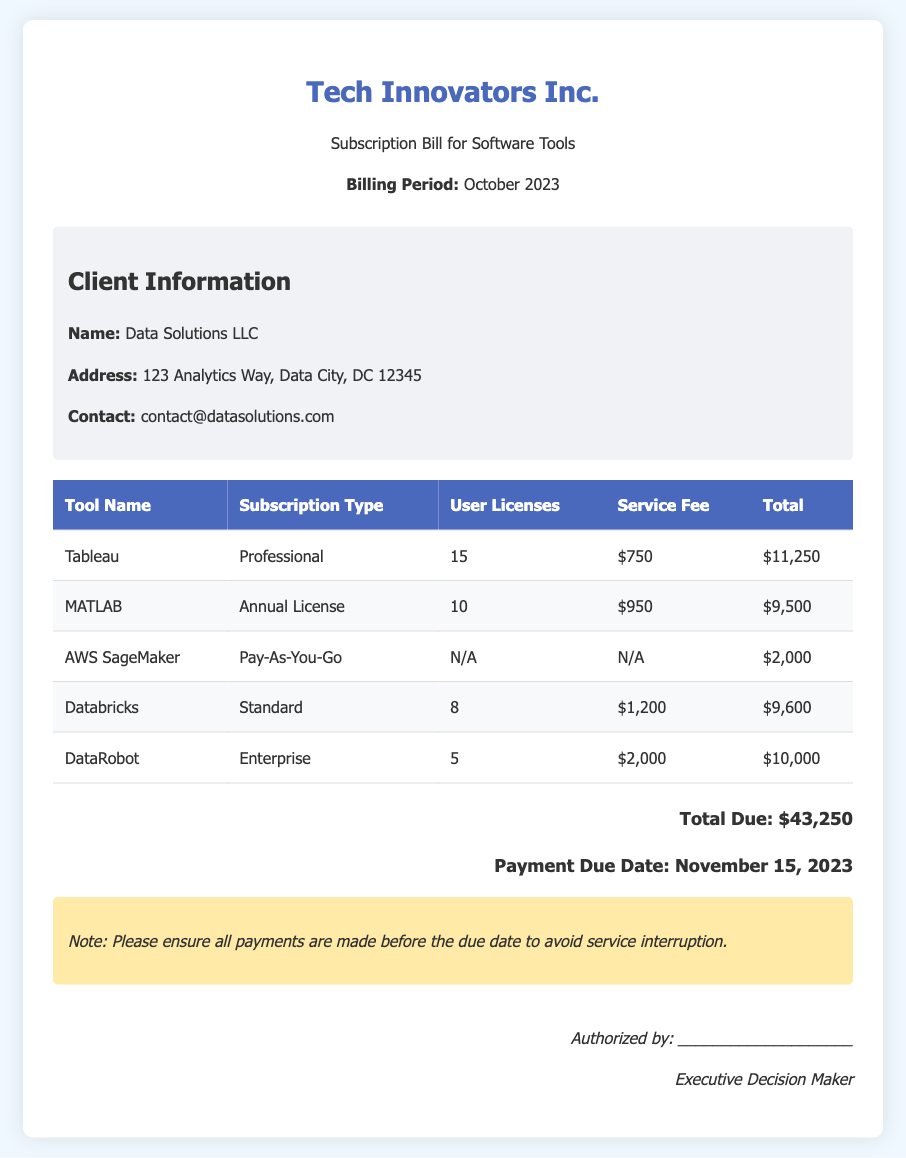What is the total due amount? The total due amount is listed at the bottom of the bill as $43,250.
Answer: $43,250 What is the payment due date? The payment due date is specified in the total section of the bill as November 15, 2023.
Answer: November 15, 2023 How many user licenses are allocated for Tableau? The number of user licenses for Tableau is stated in the table under the User Licenses column as 15.
Answer: 15 What subscription type is used for DataRobot? The subscription type for DataRobot is indicated in the table under the Subscription Type column as Enterprise.
Answer: Enterprise What is the service fee for MATLAB? The service fee for MATLAB is detailed in the table under the Service Fee column as $950.
Answer: $950 Which tool has a pay-as-you-go subscription type? The tool with a pay-as-you-go subscription type is noted as AWS SageMaker in the table.
Answer: AWS SageMaker How many total software tools are on the bill? The total number of software tools is counted from the table, which lists five different tools.
Answer: 5 Is there a note regarding payment? Yes, there is a note in the document advising to ensure all payments are made before the due date to avoid service interruption.
Answer: Yes Who is authorized to sign the bill? The authorized signatory is labeled as Executive Decision Maker at the end of the document.
Answer: Executive Decision Maker 